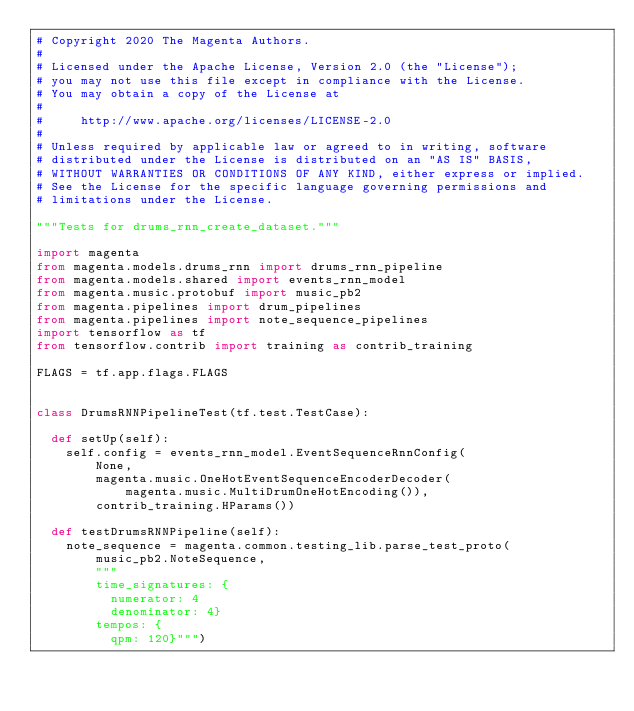Convert code to text. <code><loc_0><loc_0><loc_500><loc_500><_Python_># Copyright 2020 The Magenta Authors.
#
# Licensed under the Apache License, Version 2.0 (the "License");
# you may not use this file except in compliance with the License.
# You may obtain a copy of the License at
#
#     http://www.apache.org/licenses/LICENSE-2.0
#
# Unless required by applicable law or agreed to in writing, software
# distributed under the License is distributed on an "AS IS" BASIS,
# WITHOUT WARRANTIES OR CONDITIONS OF ANY KIND, either express or implied.
# See the License for the specific language governing permissions and
# limitations under the License.

"""Tests for drums_rnn_create_dataset."""

import magenta
from magenta.models.drums_rnn import drums_rnn_pipeline
from magenta.models.shared import events_rnn_model
from magenta.music.protobuf import music_pb2
from magenta.pipelines import drum_pipelines
from magenta.pipelines import note_sequence_pipelines
import tensorflow as tf
from tensorflow.contrib import training as contrib_training

FLAGS = tf.app.flags.FLAGS


class DrumsRNNPipelineTest(tf.test.TestCase):

  def setUp(self):
    self.config = events_rnn_model.EventSequenceRnnConfig(
        None,
        magenta.music.OneHotEventSequenceEncoderDecoder(
            magenta.music.MultiDrumOneHotEncoding()),
        contrib_training.HParams())

  def testDrumsRNNPipeline(self):
    note_sequence = magenta.common.testing_lib.parse_test_proto(
        music_pb2.NoteSequence,
        """
        time_signatures: {
          numerator: 4
          denominator: 4}
        tempos: {
          qpm: 120}""")</code> 